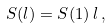Convert formula to latex. <formula><loc_0><loc_0><loc_500><loc_500>S ( l ) = S ( 1 ) \, l \, ,</formula> 